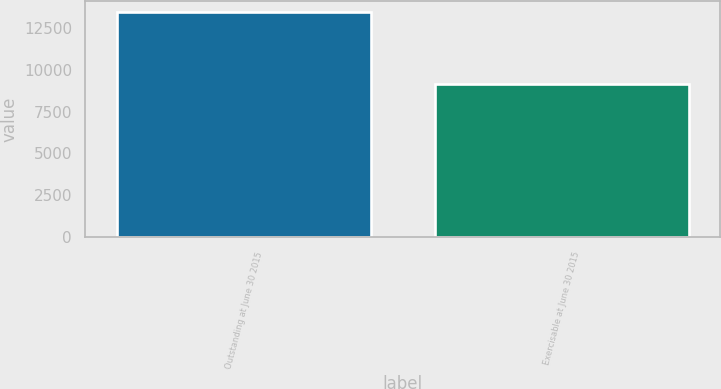Convert chart. <chart><loc_0><loc_0><loc_500><loc_500><bar_chart><fcel>Outstanding at June 30 2015<fcel>Exercisable at June 30 2015<nl><fcel>13437.1<fcel>9172.2<nl></chart> 